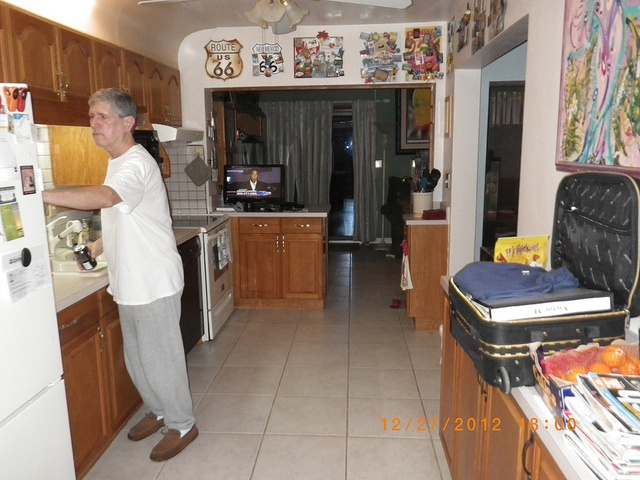Describe the objects in this image and their specific colors. I can see suitcase in tan, black, gray, and white tones, people in tan, lightgray, and darkgray tones, refrigerator in tan, lightgray, and darkgray tones, book in tan, white, darkgray, gray, and lightpink tones, and oven in tan, gray, darkgray, and maroon tones in this image. 